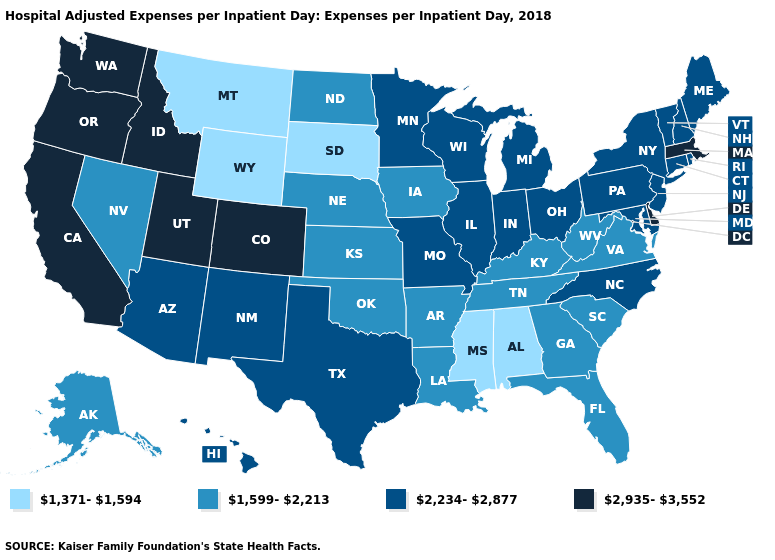What is the value of New Jersey?
Short answer required. 2,234-2,877. Does the map have missing data?
Answer briefly. No. What is the value of Mississippi?
Concise answer only. 1,371-1,594. Does Montana have the lowest value in the USA?
Be succinct. Yes. Name the states that have a value in the range 1,599-2,213?
Give a very brief answer. Alaska, Arkansas, Florida, Georgia, Iowa, Kansas, Kentucky, Louisiana, Nebraska, Nevada, North Dakota, Oklahoma, South Carolina, Tennessee, Virginia, West Virginia. Name the states that have a value in the range 1,599-2,213?
Keep it brief. Alaska, Arkansas, Florida, Georgia, Iowa, Kansas, Kentucky, Louisiana, Nebraska, Nevada, North Dakota, Oklahoma, South Carolina, Tennessee, Virginia, West Virginia. What is the value of Delaware?
Write a very short answer. 2,935-3,552. Among the states that border Pennsylvania , does Delaware have the highest value?
Keep it brief. Yes. Does the first symbol in the legend represent the smallest category?
Keep it brief. Yes. Does the first symbol in the legend represent the smallest category?
Write a very short answer. Yes. Name the states that have a value in the range 2,935-3,552?
Give a very brief answer. California, Colorado, Delaware, Idaho, Massachusetts, Oregon, Utah, Washington. Name the states that have a value in the range 2,935-3,552?
Keep it brief. California, Colorado, Delaware, Idaho, Massachusetts, Oregon, Utah, Washington. Which states have the highest value in the USA?
Concise answer only. California, Colorado, Delaware, Idaho, Massachusetts, Oregon, Utah, Washington. Which states have the highest value in the USA?
Quick response, please. California, Colorado, Delaware, Idaho, Massachusetts, Oregon, Utah, Washington. Does Wisconsin have the lowest value in the MidWest?
Concise answer only. No. 